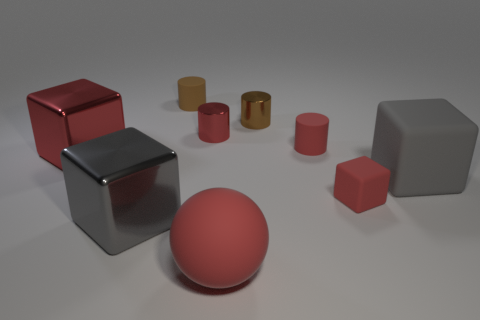What number of spheres are either large rubber things or large brown objects?
Your answer should be very brief. 1. Is the number of metal objects in front of the gray rubber block less than the number of big matte cubes?
Offer a terse response. No. What number of other objects are there of the same material as the ball?
Your answer should be very brief. 4. Is the sphere the same size as the red rubber cylinder?
Provide a succinct answer. No. How many things are either objects that are on the left side of the sphere or small brown cylinders?
Provide a succinct answer. 5. The red block behind the big gray object to the right of the small brown rubber thing is made of what material?
Make the answer very short. Metal. Is there another thing of the same shape as the brown matte object?
Provide a short and direct response. Yes. Does the brown shiny cylinder have the same size as the red object that is in front of the gray shiny cube?
Give a very brief answer. No. What number of things are either red things to the right of the big red sphere or cylinders to the left of the big red matte object?
Your response must be concise. 4. Are there more red things that are left of the large red sphere than cubes?
Give a very brief answer. No. 